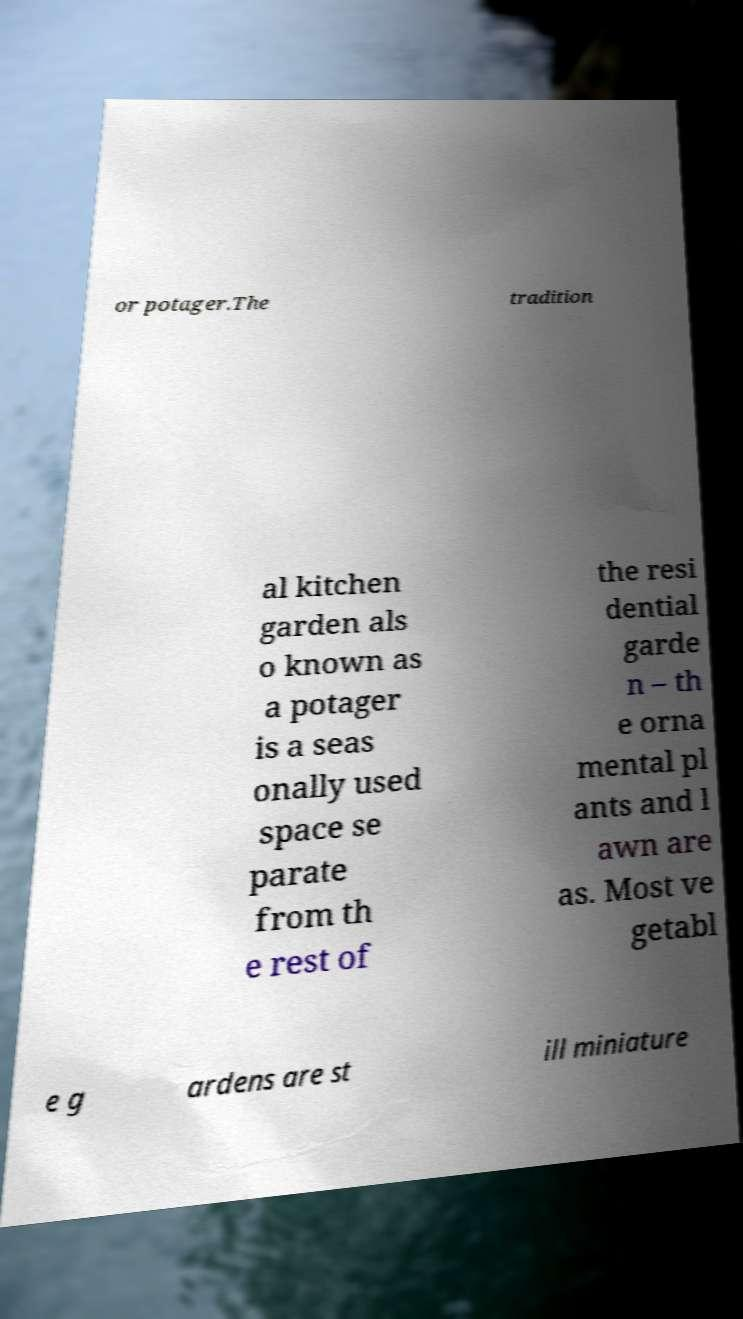Can you accurately transcribe the text from the provided image for me? or potager.The tradition al kitchen garden als o known as a potager is a seas onally used space se parate from th e rest of the resi dential garde n – th e orna mental pl ants and l awn are as. Most ve getabl e g ardens are st ill miniature 